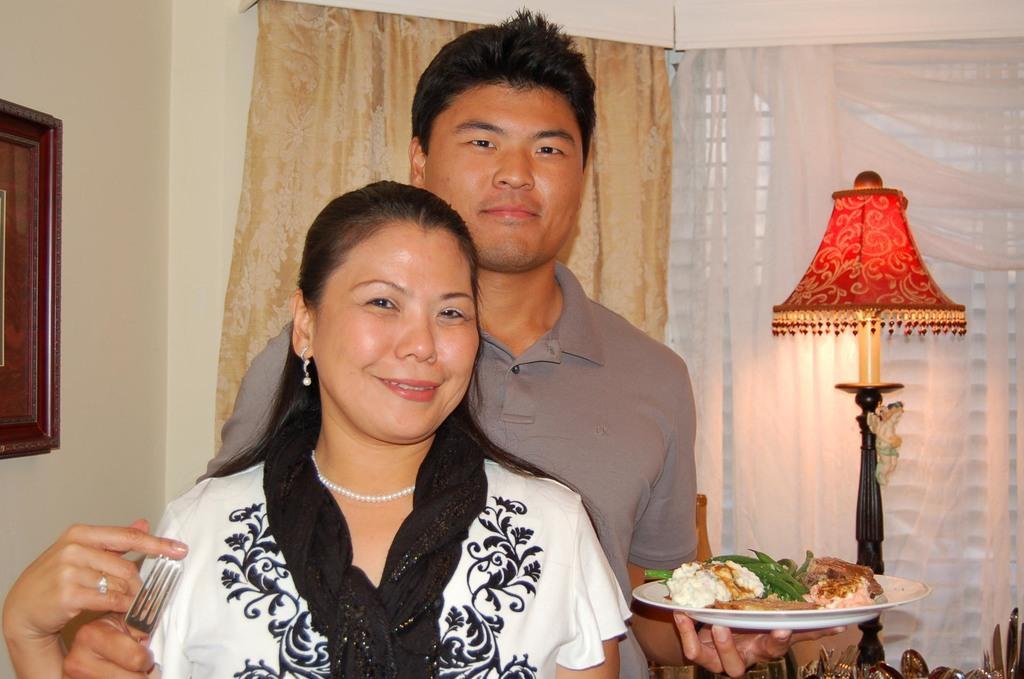Can you describe this image briefly? In this image in the center there are persons standing and smiling. In the front there is a woman standing and holding a fork in her hand, and in the center there is a man standing and holding plate in his hand. In the background there are curtains, there is a light lamp and on the wall there is a frame. 